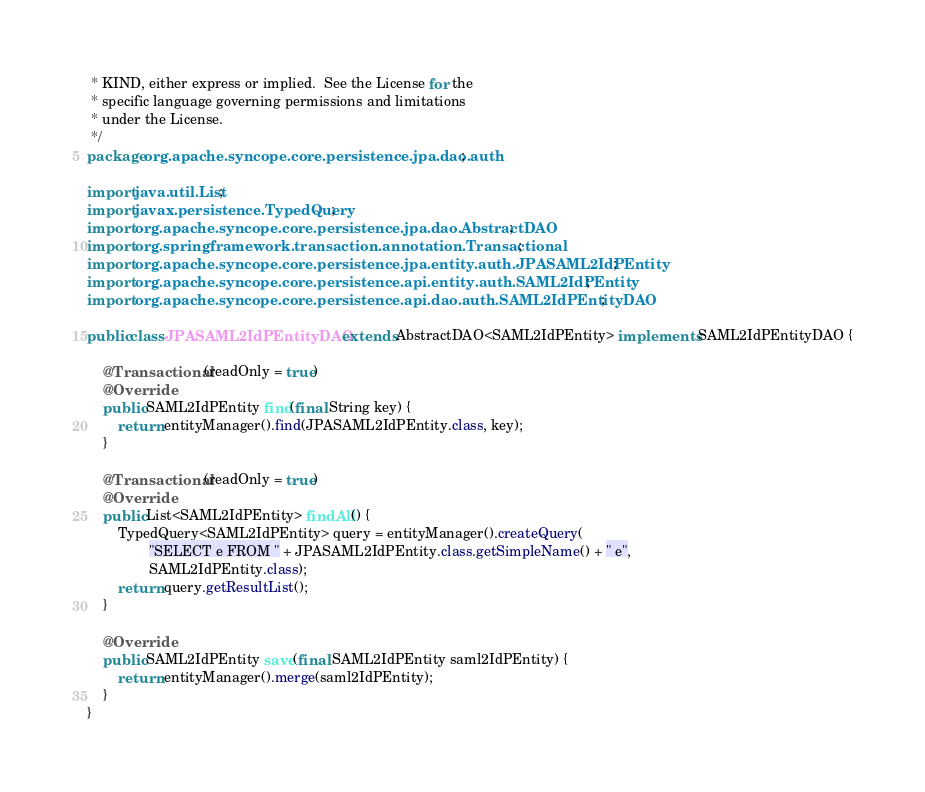<code> <loc_0><loc_0><loc_500><loc_500><_Java_> * KIND, either express or implied.  See the License for the
 * specific language governing permissions and limitations
 * under the License.
 */
package org.apache.syncope.core.persistence.jpa.dao.auth;

import java.util.List;
import javax.persistence.TypedQuery;
import org.apache.syncope.core.persistence.jpa.dao.AbstractDAO;
import org.springframework.transaction.annotation.Transactional;
import org.apache.syncope.core.persistence.jpa.entity.auth.JPASAML2IdPEntity;
import org.apache.syncope.core.persistence.api.entity.auth.SAML2IdPEntity;
import org.apache.syncope.core.persistence.api.dao.auth.SAML2IdPEntityDAO;

public class JPASAML2IdPEntityDAO extends AbstractDAO<SAML2IdPEntity> implements SAML2IdPEntityDAO {

    @Transactional(readOnly = true)
    @Override
    public SAML2IdPEntity find(final String key) {
        return entityManager().find(JPASAML2IdPEntity.class, key);
    }

    @Transactional(readOnly = true)
    @Override
    public List<SAML2IdPEntity> findAll() {
        TypedQuery<SAML2IdPEntity> query = entityManager().createQuery(
                "SELECT e FROM " + JPASAML2IdPEntity.class.getSimpleName() + " e",
                SAML2IdPEntity.class);
        return query.getResultList();
    }

    @Override
    public SAML2IdPEntity save(final SAML2IdPEntity saml2IdPEntity) {
        return entityManager().merge(saml2IdPEntity);
    }
}
</code> 